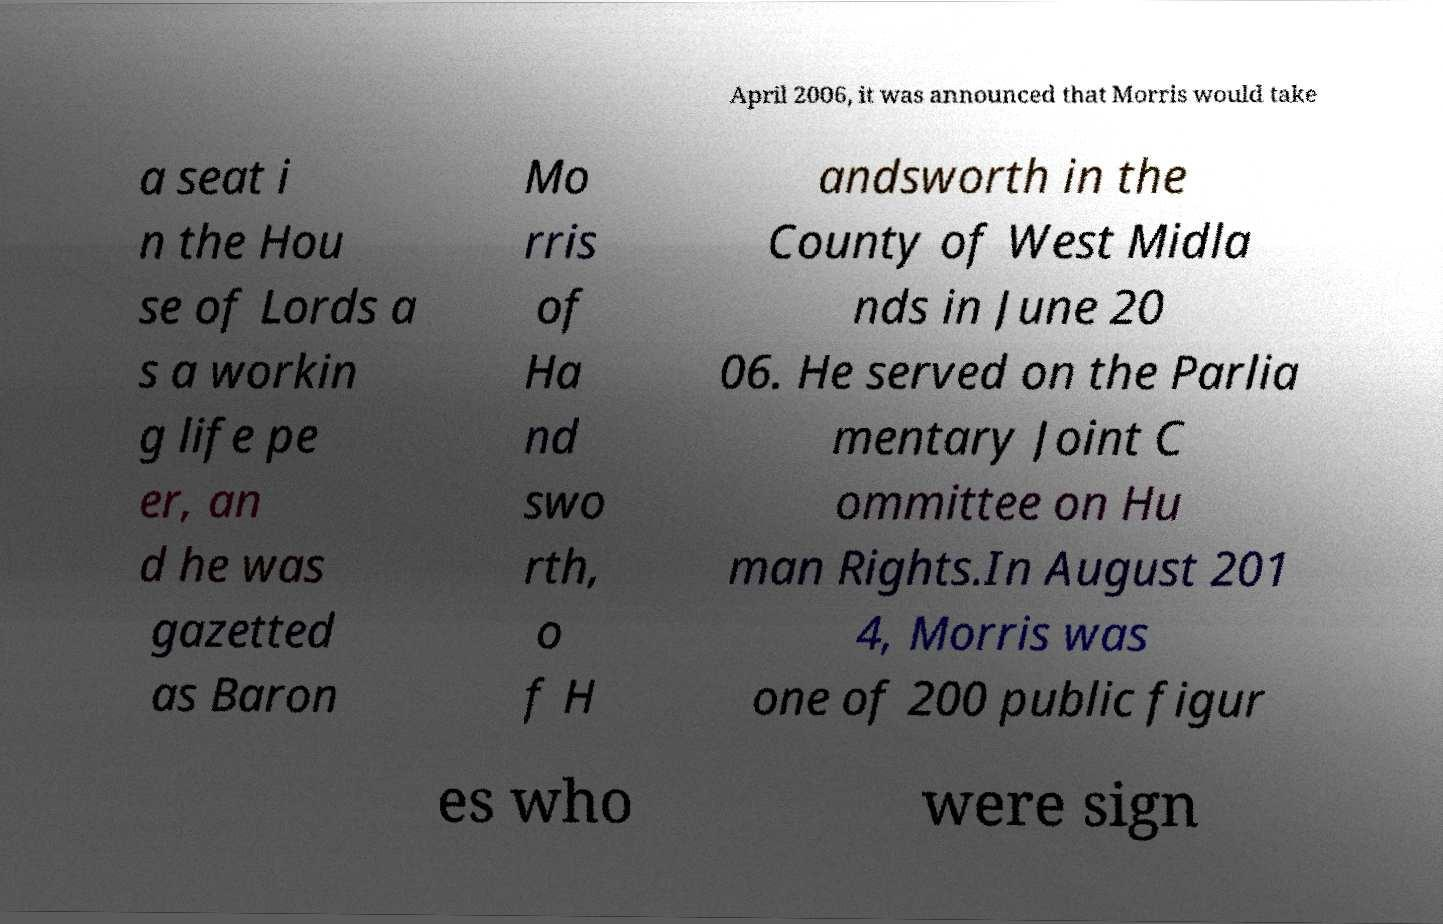Please identify and transcribe the text found in this image. April 2006, it was announced that Morris would take a seat i n the Hou se of Lords a s a workin g life pe er, an d he was gazetted as Baron Mo rris of Ha nd swo rth, o f H andsworth in the County of West Midla nds in June 20 06. He served on the Parlia mentary Joint C ommittee on Hu man Rights.In August 201 4, Morris was one of 200 public figur es who were sign 